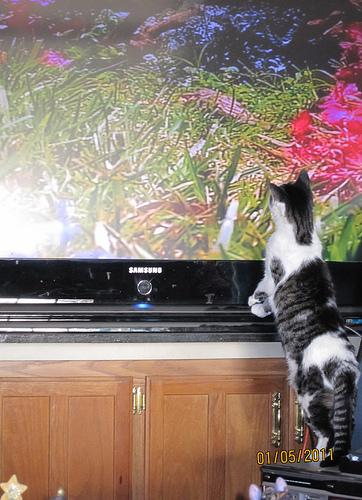Question: where was the picture taken?
Choices:
A. The living room.
B. The garage.
C. The park.
D. The beach.
Answer with the letter. Answer: A Question: how many cats are there?
Choices:
A. Two.
B. Three.
C. One.
D. Four.
Answer with the letter. Answer: C Question: where is the cat?
Choices:
A. By the door.
B. On the floor.
C. In the window.
D. In front of the television.
Answer with the letter. Answer: D Question: what is the cat looking at?
Choices:
A. The computer.
B. The phone.
C. The window.
D. The television.
Answer with the letter. Answer: D Question: what is in front of the television?
Choices:
A. The dog.
B. The child.
C. The cat.
D. The rabbit.
Answer with the letter. Answer: C 